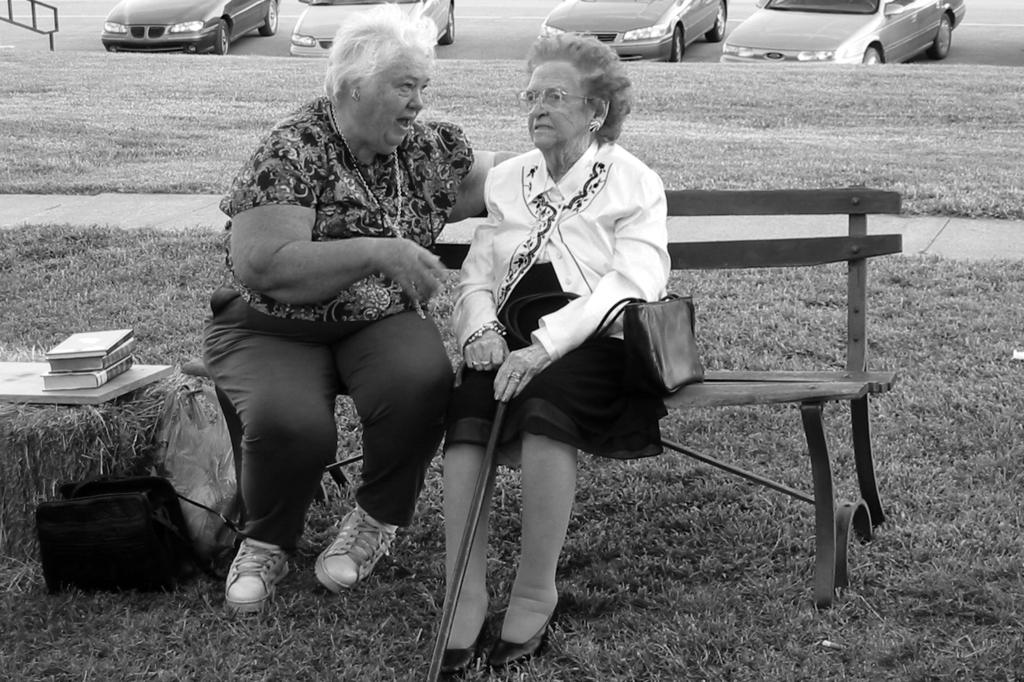How many people are in the image? There are two women in the image. What are the women doing in the image? The women are talking to each other. Where are the women sitting in the image? The women are sitting on a bench. What flavor of ice cream are the women eating in the image? There is no ice cream present in the image, so it is not possible to determine the flavor. What type of spoon is being used by the women in the image? There are no spoons present in the image, so it is not possible to determine the type of spoon being used. 